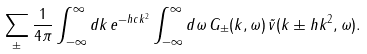Convert formula to latex. <formula><loc_0><loc_0><loc_500><loc_500>& \sum _ { \pm } \frac { 1 } { 4 \pi } \int _ { - \infty } ^ { \infty } d k \, e ^ { - h c k ^ { 2 } } \int _ { - \infty } ^ { \infty } d \omega \, G _ { \pm } ( k , \omega ) \, \tilde { v } ( k \pm h k ^ { 2 } , \omega ) .</formula> 